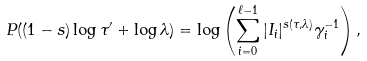<formula> <loc_0><loc_0><loc_500><loc_500>P ( ( 1 - s ) \log \tau ^ { \prime } + \log \lambda ) = \log \left ( \sum _ { i = 0 } ^ { \ell - 1 } | I _ { i } | ^ { s ( \tau , \lambda ) } \gamma _ { i } ^ { - 1 } \right ) ,</formula> 